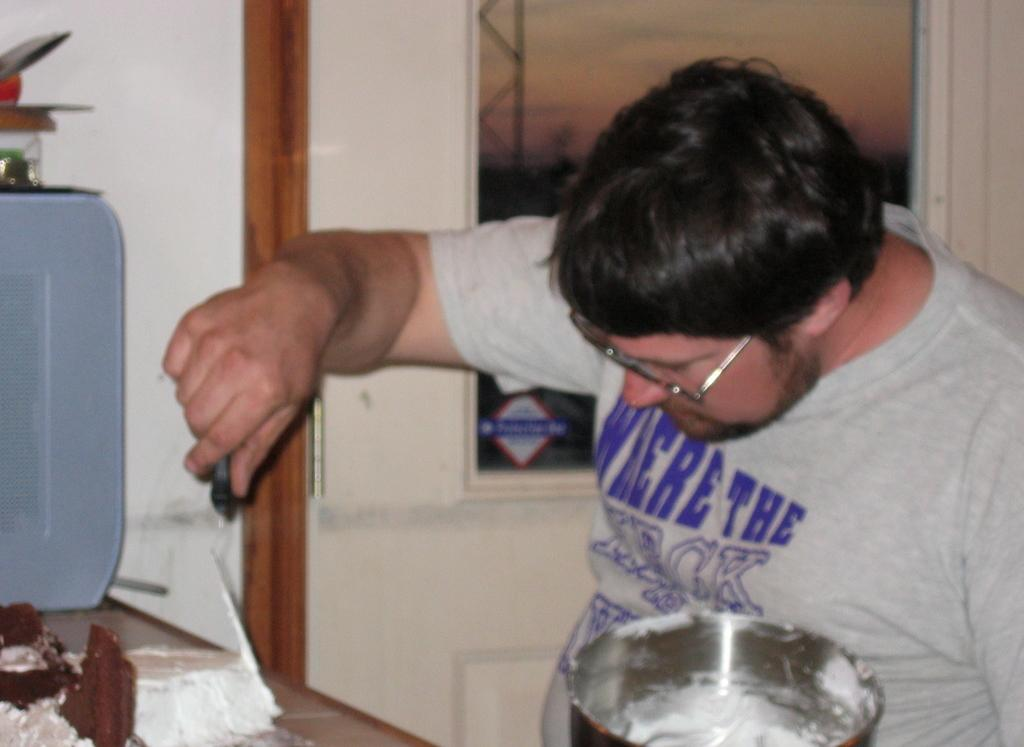<image>
Present a compact description of the photo's key features. guy icing a cake and he is wearing a shirt that states we're the and an obscured word beneath 